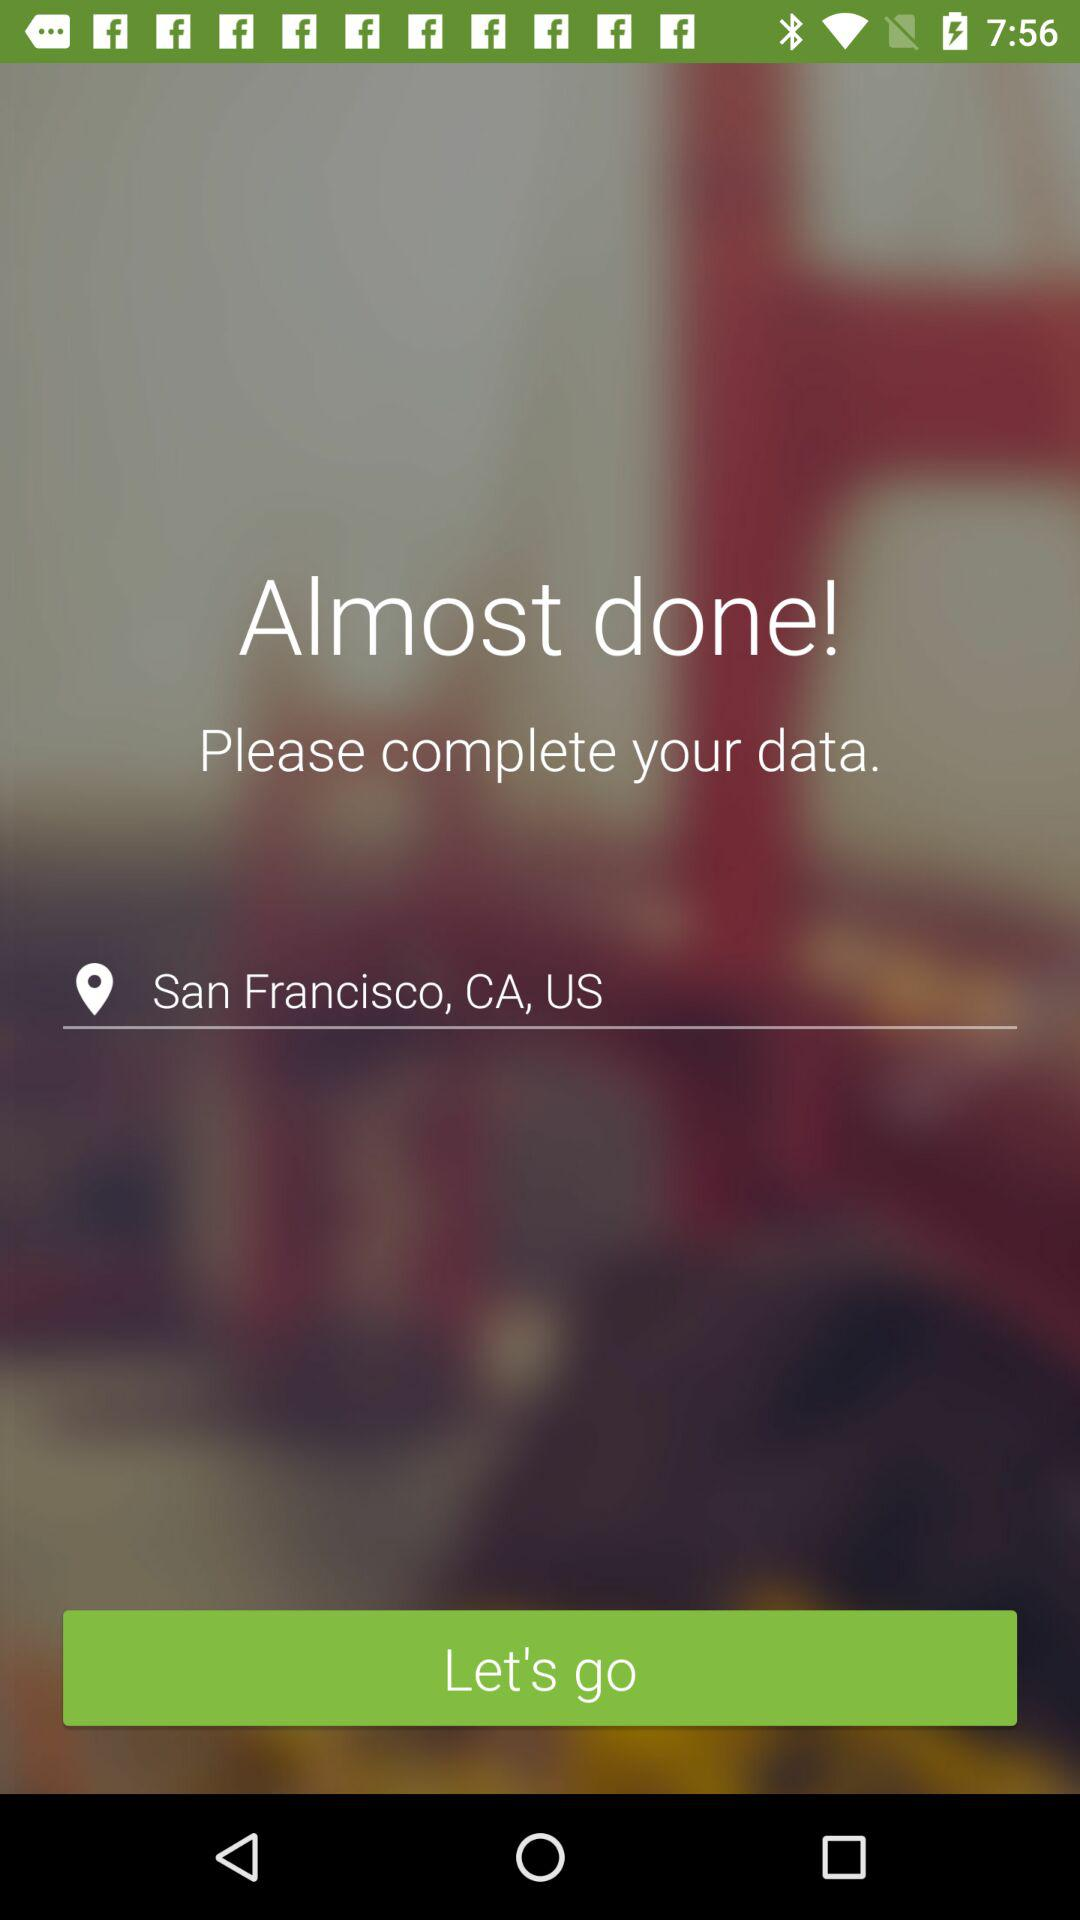What is the mentioned location? The mentioned location is San Francisco, CA, US. 